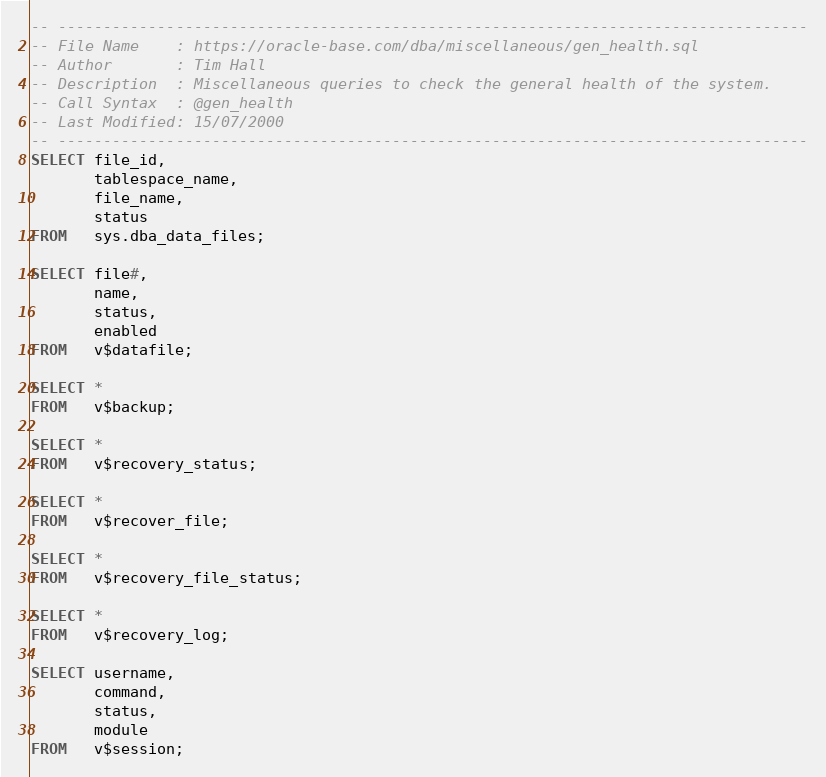Convert code to text. <code><loc_0><loc_0><loc_500><loc_500><_SQL_>-- -----------------------------------------------------------------------------------
-- File Name    : https://oracle-base.com/dba/miscellaneous/gen_health.sql
-- Author       : Tim Hall
-- Description  : Miscellaneous queries to check the general health of the system.
-- Call Syntax  : @gen_health
-- Last Modified: 15/07/2000
-- -----------------------------------------------------------------------------------
SELECT file_id, 
       tablespace_name, 
       file_name, 
       status 
FROM   sys.dba_data_files; 

SELECT file#, 
       name, 
       status, 
       enabled 
FROM   v$datafile;

SELECT * 
FROM   v$backup;

SELECT * 
FROM   v$recovery_status;

SELECT * 
FROM   v$recover_file;

SELECT * 
FROM   v$recovery_file_status;

SELECT * 
FROM   v$recovery_log;

SELECT username, 
       command, 
       status, 
       module 
FROM   v$session;

</code> 